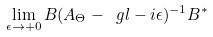Convert formula to latex. <formula><loc_0><loc_0><loc_500><loc_500>\lim _ { \epsilon \to + 0 } B ( A _ { \Theta } - \ g l - i \epsilon ) ^ { - 1 } B ^ { * }</formula> 